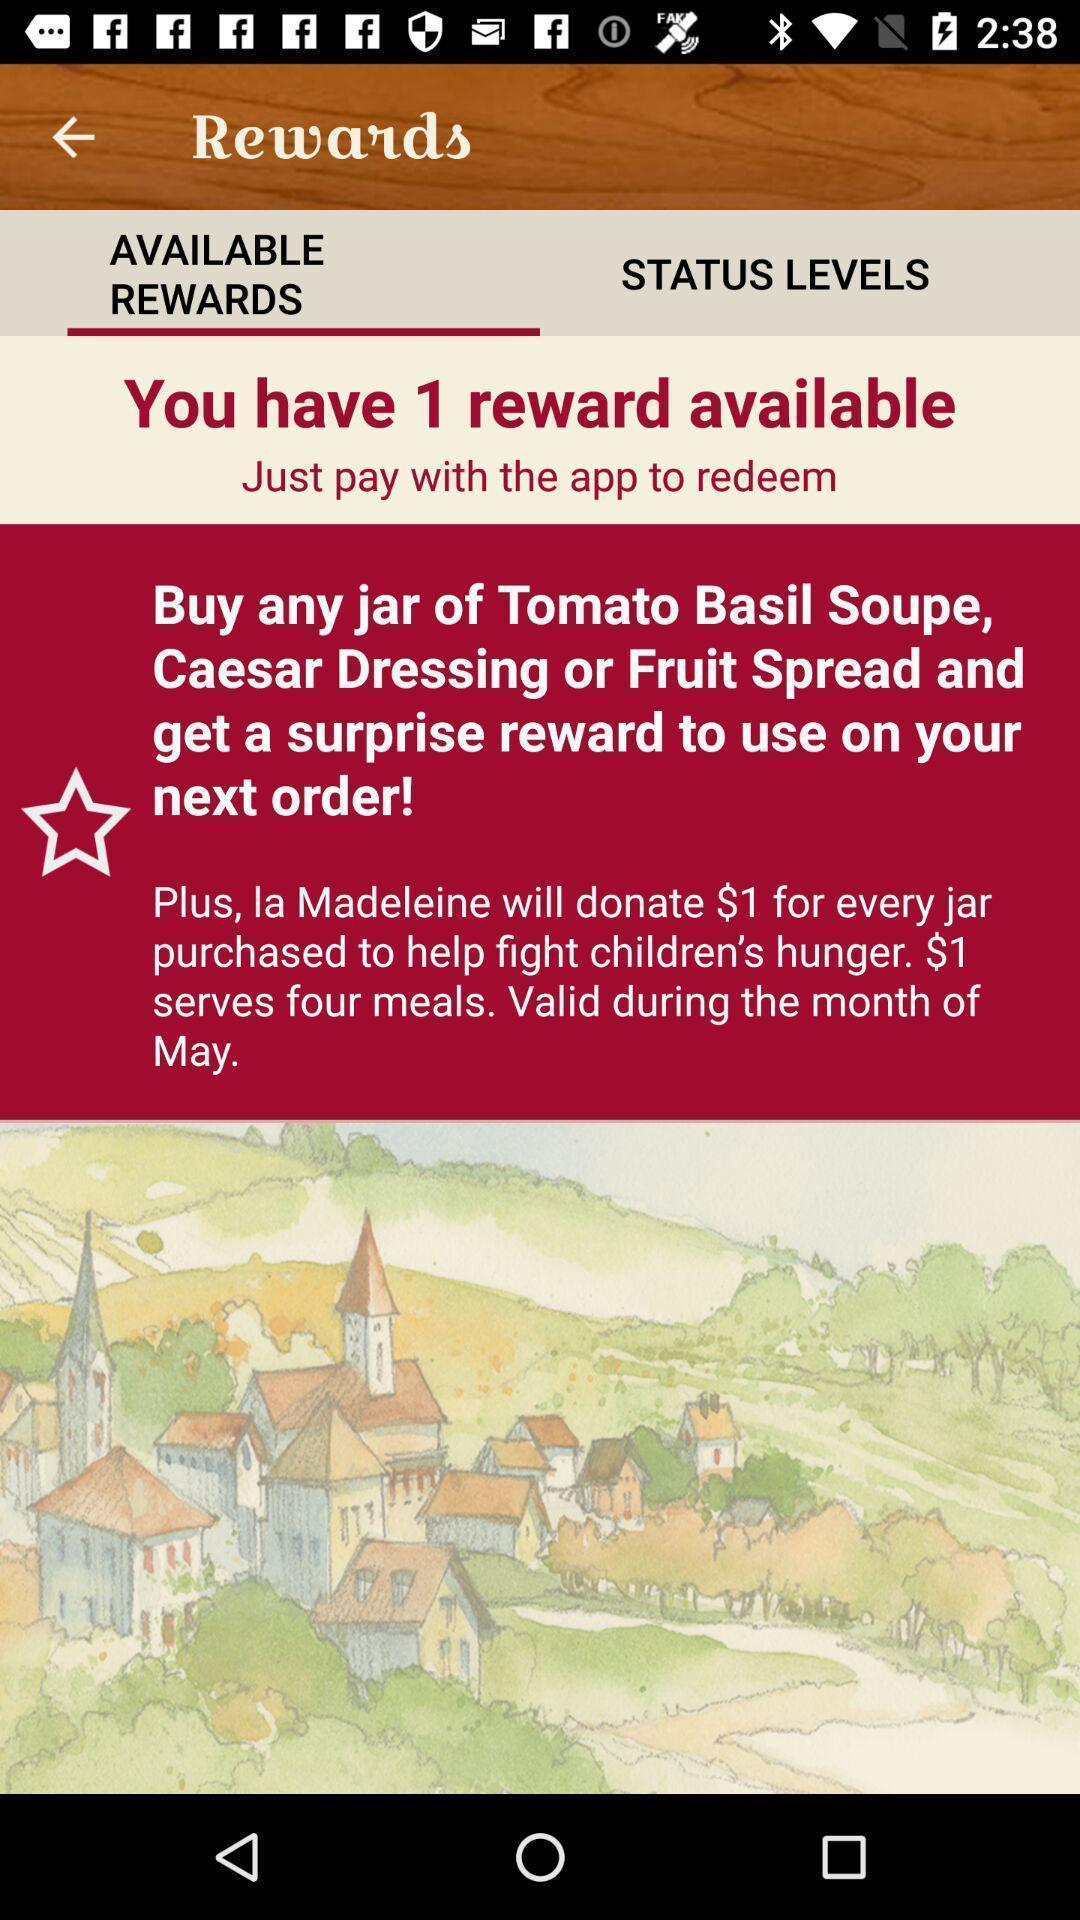Provide a description of this screenshot. Screen displaying contents in rewards page. 